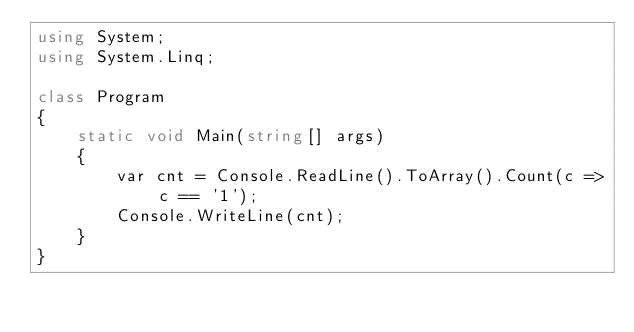<code> <loc_0><loc_0><loc_500><loc_500><_C#_>using System;
using System.Linq;

class Program
{
    static void Main(string[] args)
    {
        var cnt = Console.ReadLine().ToArray().Count(c => c == '1');
        Console.WriteLine(cnt);
    }
}</code> 